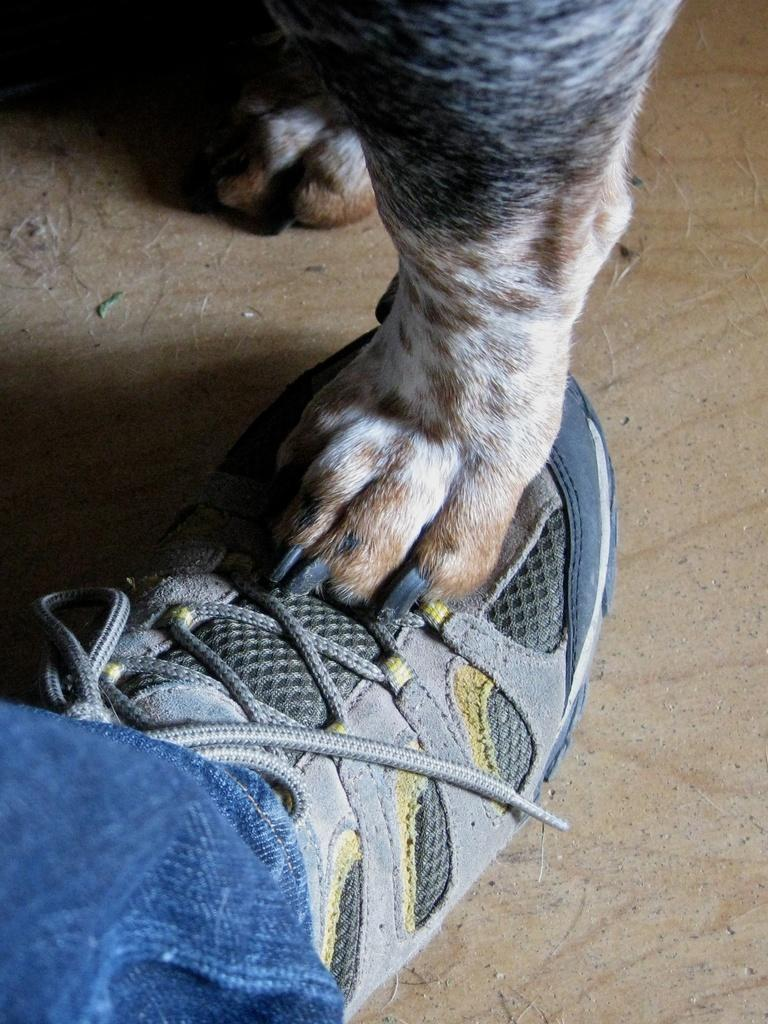What object is the main focus of the image? There is a shoe in the image. What additional detail can be observed on the shoe? The leg of an animal is visible on the shoe. Are there any other clothing items visible in the image? Yes, there is a pair of blue color jeans in the bottom left corner of the image. What type of reason can be seen in the image? There is no reason present in the image; it features a shoe with an animal leg and blue color jeans. Can you tell me how many fairies are dancing on the shoe in the image? There are no fairies present in the image; it only shows a shoe with an animal leg and blue color jeans. 